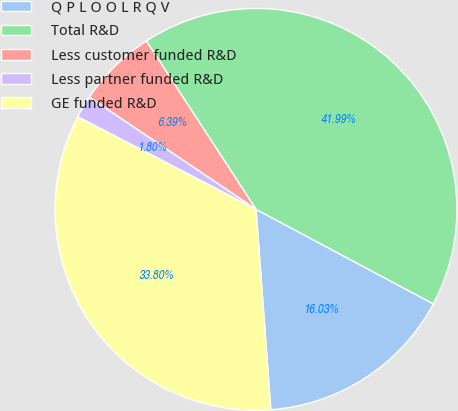<chart> <loc_0><loc_0><loc_500><loc_500><pie_chart><fcel>Q P L O O L R Q V<fcel>Total R&D<fcel>Less customer funded R&D<fcel>Less partner funded R&D<fcel>GE funded R&D<nl><fcel>16.03%<fcel>41.99%<fcel>6.39%<fcel>1.8%<fcel>33.8%<nl></chart> 